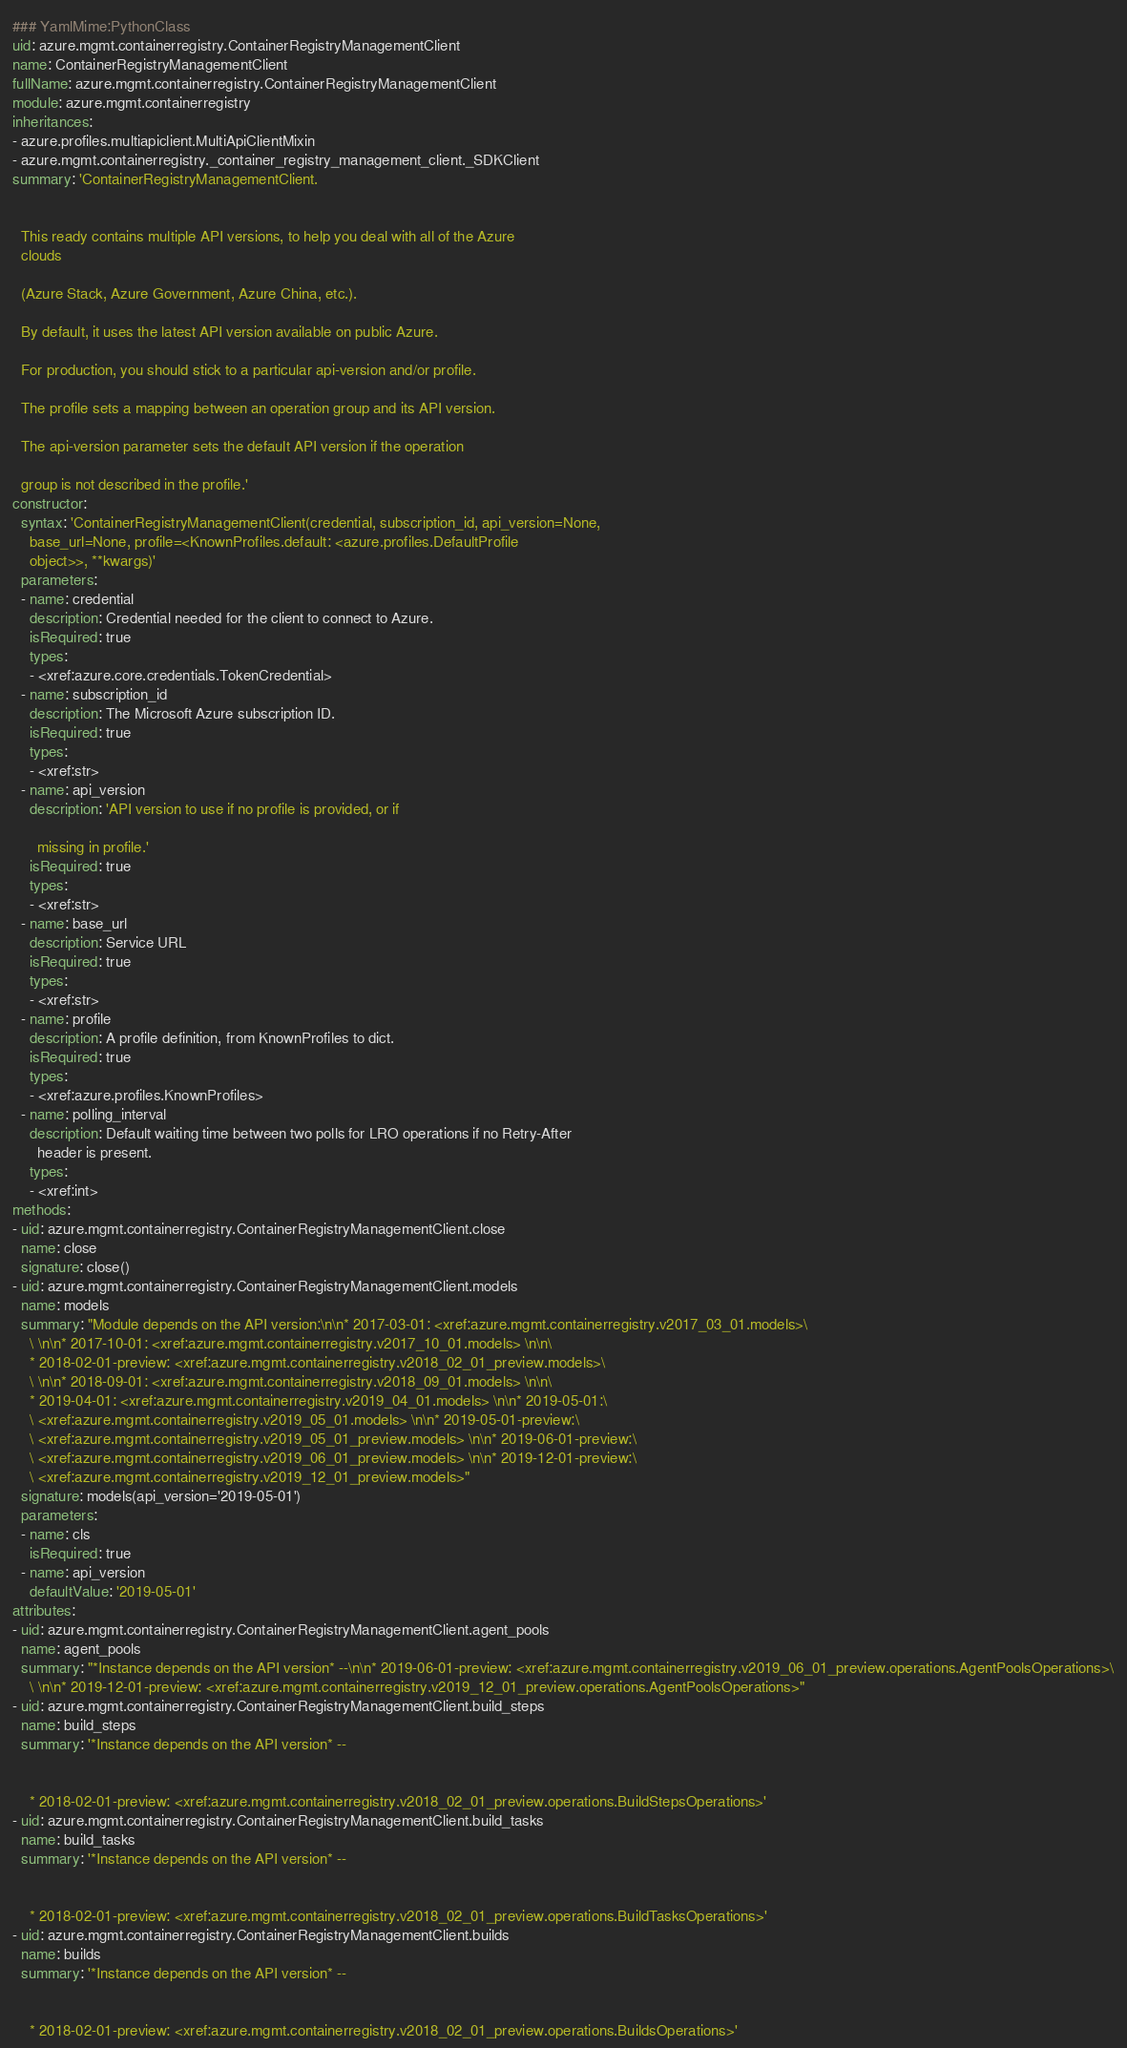<code> <loc_0><loc_0><loc_500><loc_500><_YAML_>### YamlMime:PythonClass
uid: azure.mgmt.containerregistry.ContainerRegistryManagementClient
name: ContainerRegistryManagementClient
fullName: azure.mgmt.containerregistry.ContainerRegistryManagementClient
module: azure.mgmt.containerregistry
inheritances:
- azure.profiles.multiapiclient.MultiApiClientMixin
- azure.mgmt.containerregistry._container_registry_management_client._SDKClient
summary: 'ContainerRegistryManagementClient.


  This ready contains multiple API versions, to help you deal with all of the Azure
  clouds

  (Azure Stack, Azure Government, Azure China, etc.).

  By default, it uses the latest API version available on public Azure.

  For production, you should stick to a particular api-version and/or profile.

  The profile sets a mapping between an operation group and its API version.

  The api-version parameter sets the default API version if the operation

  group is not described in the profile.'
constructor:
  syntax: 'ContainerRegistryManagementClient(credential, subscription_id, api_version=None,
    base_url=None, profile=<KnownProfiles.default: <azure.profiles.DefaultProfile
    object>>, **kwargs)'
  parameters:
  - name: credential
    description: Credential needed for the client to connect to Azure.
    isRequired: true
    types:
    - <xref:azure.core.credentials.TokenCredential>
  - name: subscription_id
    description: The Microsoft Azure subscription ID.
    isRequired: true
    types:
    - <xref:str>
  - name: api_version
    description: 'API version to use if no profile is provided, or if

      missing in profile.'
    isRequired: true
    types:
    - <xref:str>
  - name: base_url
    description: Service URL
    isRequired: true
    types:
    - <xref:str>
  - name: profile
    description: A profile definition, from KnownProfiles to dict.
    isRequired: true
    types:
    - <xref:azure.profiles.KnownProfiles>
  - name: polling_interval
    description: Default waiting time between two polls for LRO operations if no Retry-After
      header is present.
    types:
    - <xref:int>
methods:
- uid: azure.mgmt.containerregistry.ContainerRegistryManagementClient.close
  name: close
  signature: close()
- uid: azure.mgmt.containerregistry.ContainerRegistryManagementClient.models
  name: models
  summary: "Module depends on the API version:\n\n* 2017-03-01: <xref:azure.mgmt.containerregistry.v2017_03_01.models>\
    \ \n\n* 2017-10-01: <xref:azure.mgmt.containerregistry.v2017_10_01.models> \n\n\
    * 2018-02-01-preview: <xref:azure.mgmt.containerregistry.v2018_02_01_preview.models>\
    \ \n\n* 2018-09-01: <xref:azure.mgmt.containerregistry.v2018_09_01.models> \n\n\
    * 2019-04-01: <xref:azure.mgmt.containerregistry.v2019_04_01.models> \n\n* 2019-05-01:\
    \ <xref:azure.mgmt.containerregistry.v2019_05_01.models> \n\n* 2019-05-01-preview:\
    \ <xref:azure.mgmt.containerregistry.v2019_05_01_preview.models> \n\n* 2019-06-01-preview:\
    \ <xref:azure.mgmt.containerregistry.v2019_06_01_preview.models> \n\n* 2019-12-01-preview:\
    \ <xref:azure.mgmt.containerregistry.v2019_12_01_preview.models>"
  signature: models(api_version='2019-05-01')
  parameters:
  - name: cls
    isRequired: true
  - name: api_version
    defaultValue: '2019-05-01'
attributes:
- uid: azure.mgmt.containerregistry.ContainerRegistryManagementClient.agent_pools
  name: agent_pools
  summary: "*Instance depends on the API version* --\n\n* 2019-06-01-preview: <xref:azure.mgmt.containerregistry.v2019_06_01_preview.operations.AgentPoolsOperations>\
    \ \n\n* 2019-12-01-preview: <xref:azure.mgmt.containerregistry.v2019_12_01_preview.operations.AgentPoolsOperations>"
- uid: azure.mgmt.containerregistry.ContainerRegistryManagementClient.build_steps
  name: build_steps
  summary: '*Instance depends on the API version* --


    * 2018-02-01-preview: <xref:azure.mgmt.containerregistry.v2018_02_01_preview.operations.BuildStepsOperations>'
- uid: azure.mgmt.containerregistry.ContainerRegistryManagementClient.build_tasks
  name: build_tasks
  summary: '*Instance depends on the API version* --


    * 2018-02-01-preview: <xref:azure.mgmt.containerregistry.v2018_02_01_preview.operations.BuildTasksOperations>'
- uid: azure.mgmt.containerregistry.ContainerRegistryManagementClient.builds
  name: builds
  summary: '*Instance depends on the API version* --


    * 2018-02-01-preview: <xref:azure.mgmt.containerregistry.v2018_02_01_preview.operations.BuildsOperations>'</code> 